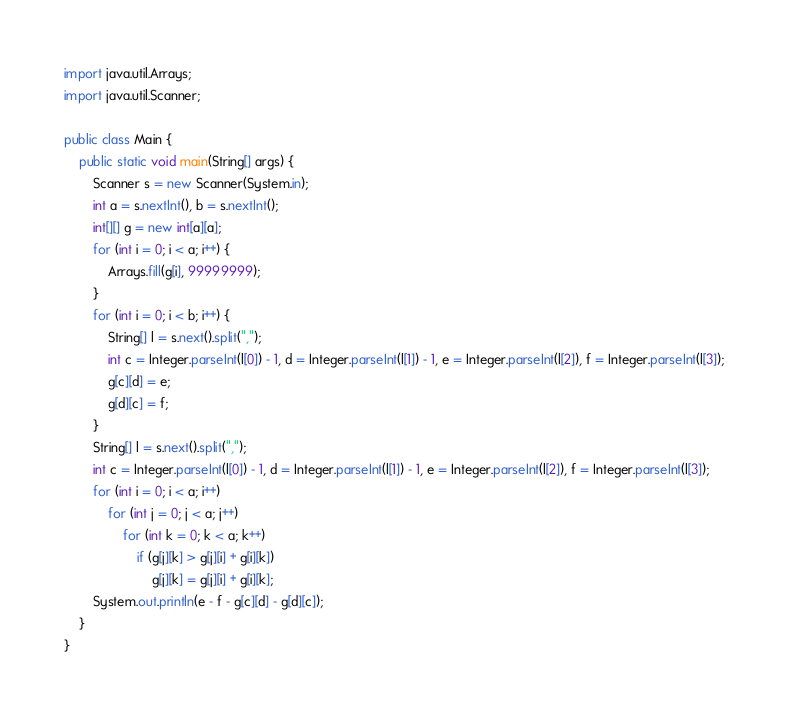<code> <loc_0><loc_0><loc_500><loc_500><_Java_>import java.util.Arrays;
import java.util.Scanner;

public class Main {
    public static void main(String[] args) {
        Scanner s = new Scanner(System.in);
        int a = s.nextInt(), b = s.nextInt();
        int[][] g = new int[a][a];
        for (int i = 0; i < a; i++) {
            Arrays.fill(g[i], 99999999);
        }
        for (int i = 0; i < b; i++) {
            String[] l = s.next().split(",");
            int c = Integer.parseInt(l[0]) - 1, d = Integer.parseInt(l[1]) - 1, e = Integer.parseInt(l[2]), f = Integer.parseInt(l[3]);
            g[c][d] = e;
            g[d][c] = f;
        }
        String[] l = s.next().split(",");
        int c = Integer.parseInt(l[0]) - 1, d = Integer.parseInt(l[1]) - 1, e = Integer.parseInt(l[2]), f = Integer.parseInt(l[3]);
        for (int i = 0; i < a; i++)
            for (int j = 0; j < a; j++)
                for (int k = 0; k < a; k++)
                    if (g[j][k] > g[j][i] + g[i][k])
                        g[j][k] = g[j][i] + g[i][k];
        System.out.println(e - f - g[c][d] - g[d][c]);
    }
}

</code> 